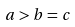Convert formula to latex. <formula><loc_0><loc_0><loc_500><loc_500>a > b = c</formula> 